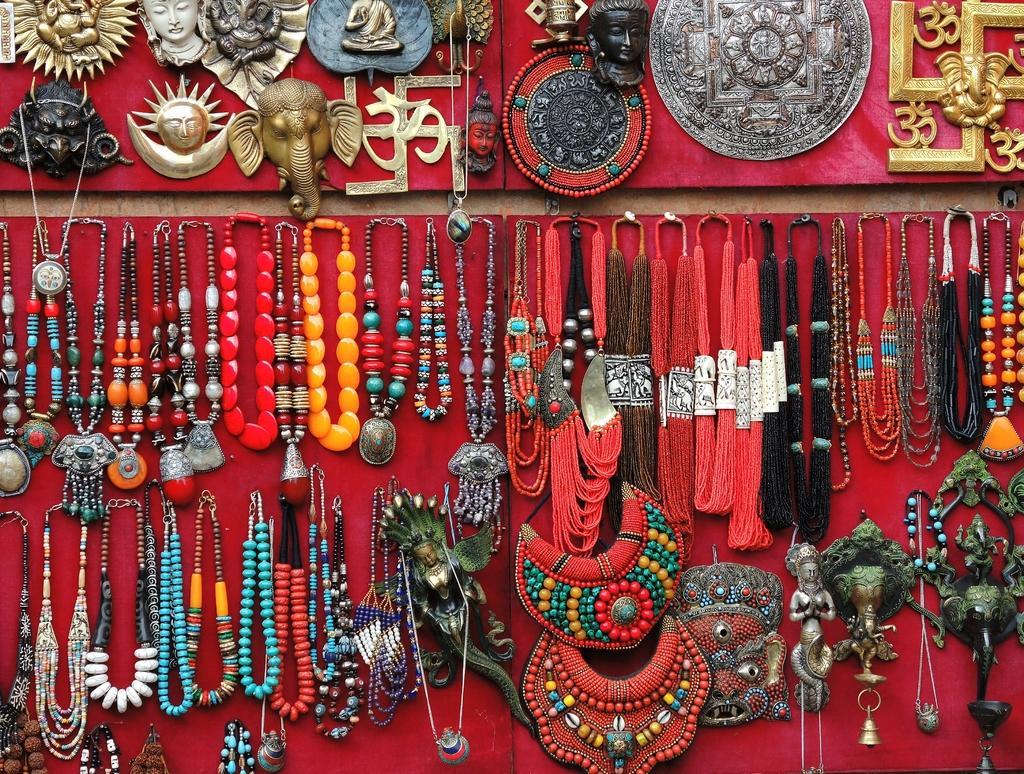Can you describe this image briefly? In this image there are many neck pieces and antique pieces on the board. There is a red colored cloth on the board. There are many antiques. 